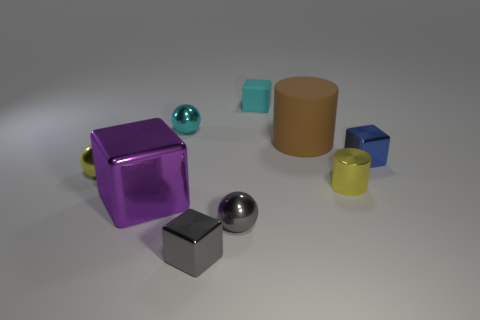There is a cube on the left side of the gray cube; what is its color?
Give a very brief answer. Purple. There is another tiny object that is the same color as the small rubber object; what is its material?
Offer a very short reply. Metal. Are there any other big green rubber objects of the same shape as the big matte thing?
Give a very brief answer. No. How many big brown objects have the same shape as the small cyan metal thing?
Offer a very short reply. 0. Is the small shiny cylinder the same color as the big matte cylinder?
Offer a very short reply. No. Are there fewer metallic spheres than tiny objects?
Your answer should be compact. Yes. What is the material of the yellow cylinder in front of the big matte thing?
Provide a succinct answer. Metal. What material is the cyan ball that is the same size as the blue shiny block?
Your answer should be compact. Metal. The cylinder behind the yellow metal thing that is to the left of the large thing that is in front of the brown cylinder is made of what material?
Offer a terse response. Rubber. There is a cube that is behind the blue shiny thing; is its size the same as the small cyan metal object?
Offer a terse response. Yes. 